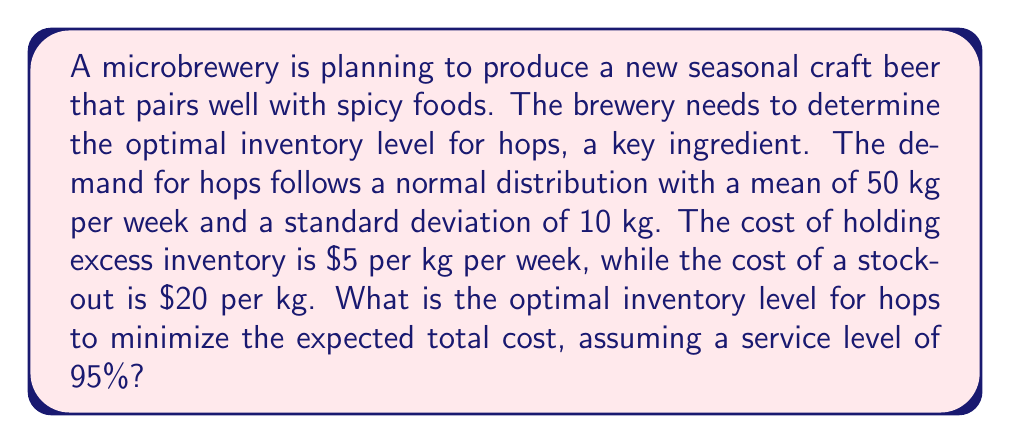Give your solution to this math problem. To solve this problem, we'll use the newsvendor model, which is ideal for determining optimal inventory levels for perishable goods or seasonal items.

1. First, we need to calculate the critical ratio (CR) using the given costs:
   
   $$ CR = \frac{C_u}{C_u + C_o} $$
   
   Where $C_u$ is the unit cost of understocking (stockout cost) and $C_o$ is the unit cost of overstocking (holding cost).

   $$ CR = \frac{20}{20 + 5} = \frac{20}{25} = 0.8 $$

2. The service level of 95% corresponds to a z-score of 1.645 in the standard normal distribution. Since our calculated CR (0.8) is less than 0.95, we'll use the CR to determine the optimal inventory level.

3. We need to find the z-score that corresponds to our CR of 0.8. Using a standard normal distribution table or calculator, we find that the z-score for 0.8 is approximately 0.84.

4. Now we can calculate the optimal inventory level (Q*) using the formula:

   $$ Q* = \mu + z\sigma $$

   Where $\mu$ is the mean demand, $z$ is the z-score, and $\sigma$ is the standard deviation.

   $$ Q* = 50 + (0.84 \times 10) = 50 + 8.4 = 58.4 \text{ kg} $$

5. Since we can't order a fractional amount of hops, we round up to the nearest whole number.
Answer: The optimal inventory level for hops is 59 kg per week. 